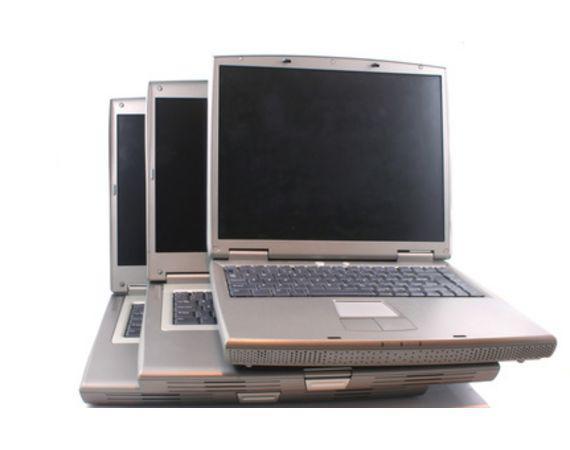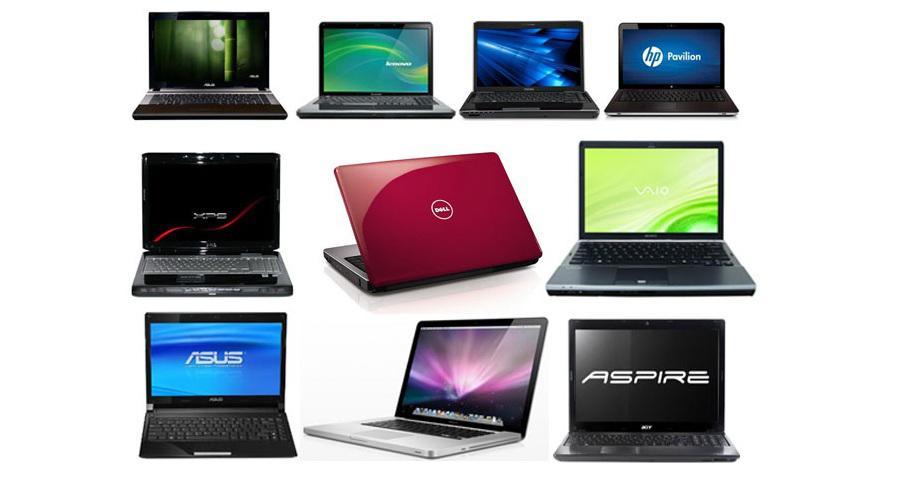The first image is the image on the left, the second image is the image on the right. For the images displayed, is the sentence "Three computers are displayed in the image on the right." factually correct? Answer yes or no. No. The first image is the image on the left, the second image is the image on the right. Assess this claim about the two images: "One image shows a brown desk with three computer screens visible on top of it.". Correct or not? Answer yes or no. No. 